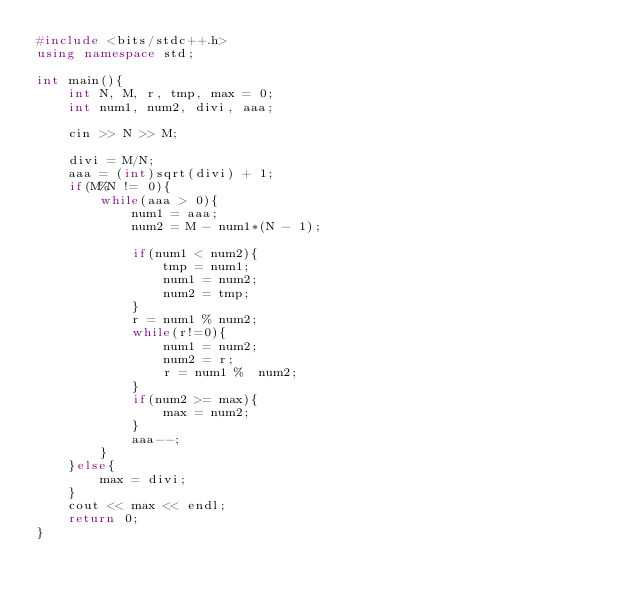Convert code to text. <code><loc_0><loc_0><loc_500><loc_500><_C++_>#include <bits/stdc++.h>
using namespace std;

int main(){
    int N, M, r, tmp, max = 0;
    int num1, num2, divi, aaa;

    cin >> N >> M;

    divi = M/N;
    aaa = (int)sqrt(divi) + 1;
    if(M%N != 0){
        while(aaa > 0){
            num1 = aaa;
            num2 = M - num1*(N - 1);

            if(num1 < num2){
                tmp = num1;
                num1 = num2;
                num2 = tmp;
            }
            r = num1 % num2;
            while(r!=0){
                num1 = num2;
                num2 = r;
                r = num1 %  num2;
            }
            if(num2 >= max){
                max = num2;
            }
            aaa--;
        }
    }else{
        max = divi;
    }
    cout << max << endl;
    return 0;
}
</code> 